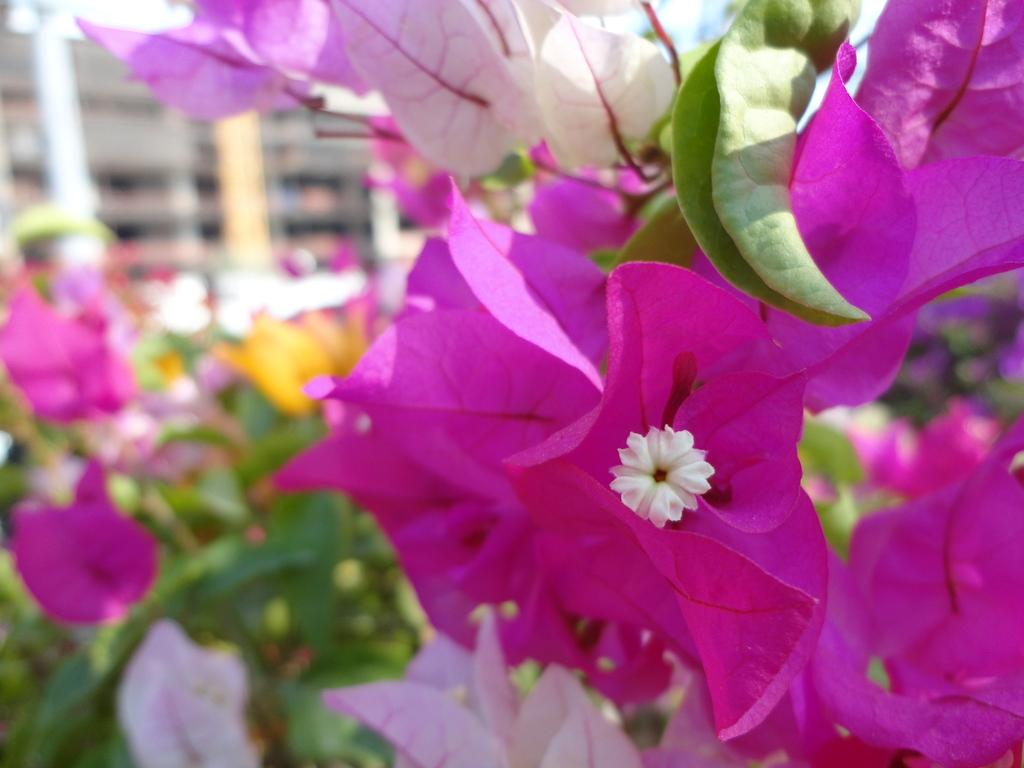What is the main subject in the center of the image? There are flowers in the center of the image. What can be seen in the background of the image? There appear to be windows in the background of the image. What type of cork can be seen holding the flowers in the image? There is no cork present in the image; the flowers are not being held by any visible object. 